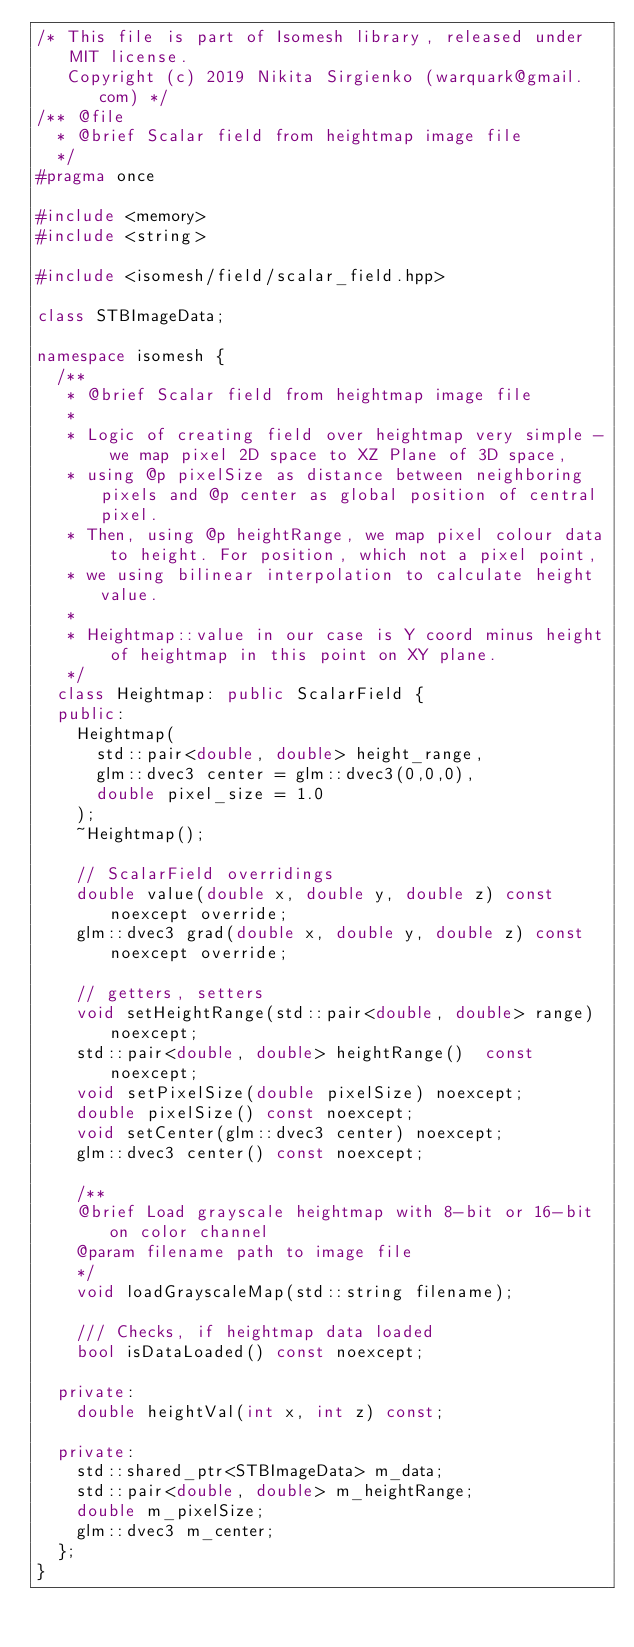Convert code to text. <code><loc_0><loc_0><loc_500><loc_500><_C++_>/* This file is part of Isomesh library, released under MIT license.
   Copyright (c) 2019 Nikita Sirgienko (warquark@gmail.com) */
/** @file 
  * @brief Scalar field from heightmap image file
  */
#pragma once

#include <memory>
#include <string>

#include <isomesh/field/scalar_field.hpp>

class STBImageData;

namespace isomesh {
	/**
	 * @brief Scalar field from heightmap image file
	 *
	 * Logic of creating field over heightmap very simple - we map pixel 2D space to XZ Plane of 3D space,
	 * using @p pixelSize as distance between neighboring pixels and @p center as global position of central pixel.
	 * Then, using @p heightRange, we map pixel colour data to height. For position, which not a pixel point,
	 * we using bilinear interpolation to calculate height value.
	 *
	 * Heightmap::value in our case is Y coord minus height of heightmap in this point on XY plane.
	 */
	class Heightmap: public ScalarField {
	public:
		Heightmap(
			std::pair<double, double> height_range,
			glm::dvec3 center = glm::dvec3(0,0,0),
			double pixel_size = 1.0
		);
		~Heightmap();

		// ScalarField overridings
		double value(double x, double y, double z) const noexcept override;
		glm::dvec3 grad(double x, double y, double z) const noexcept override;

		// getters, setters
		void setHeightRange(std::pair<double, double> range) noexcept;
		std::pair<double, double> heightRange()  const noexcept;
		void setPixelSize(double pixelSize) noexcept;
		double pixelSize() const noexcept;
		void setCenter(glm::dvec3 center) noexcept;
		glm::dvec3 center() const noexcept;

		/**
		@brief Load grayscale heightmap with 8-bit or 16-bit on color channel
		@param filename path to image file
		*/
		void loadGrayscaleMap(std::string filename);

		/// Checks, if heightmap data loaded
		bool isDataLoaded() const noexcept;

	private:
		double heightVal(int x, int z) const;

	private:
		std::shared_ptr<STBImageData> m_data;
		std::pair<double, double> m_heightRange;
		double m_pixelSize;
		glm::dvec3 m_center;
	};
}
</code> 